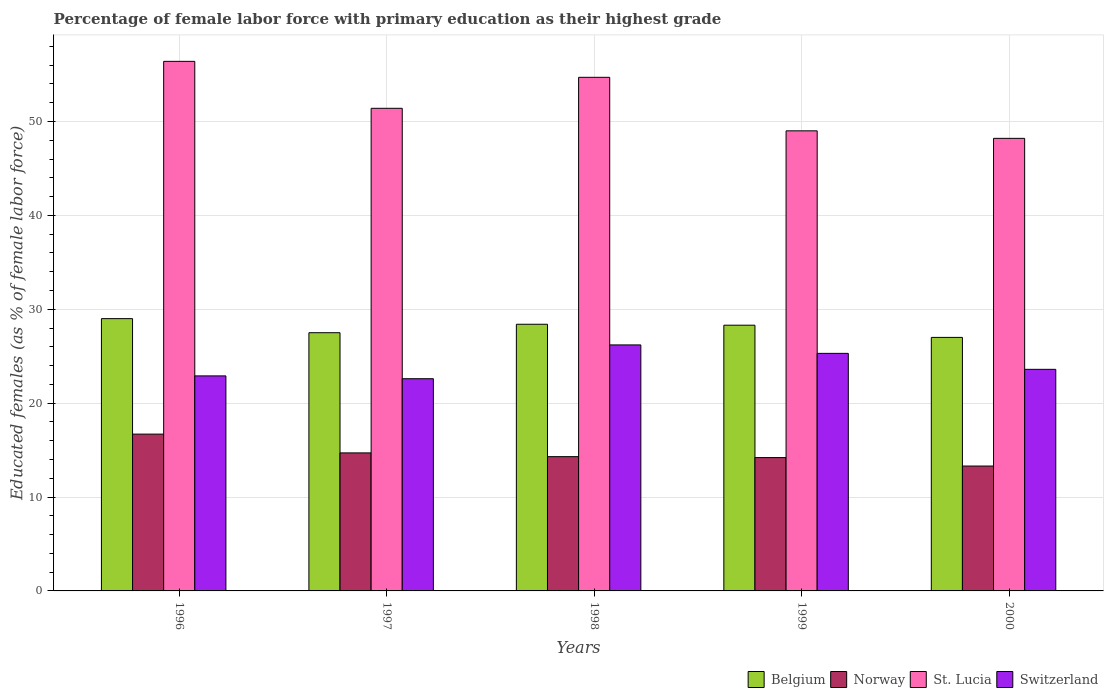How many groups of bars are there?
Offer a terse response. 5. Are the number of bars per tick equal to the number of legend labels?
Keep it short and to the point. Yes. How many bars are there on the 1st tick from the right?
Make the answer very short. 4. What is the label of the 3rd group of bars from the left?
Give a very brief answer. 1998. What is the percentage of female labor force with primary education in Switzerland in 1996?
Provide a succinct answer. 22.9. Across all years, what is the maximum percentage of female labor force with primary education in St. Lucia?
Provide a short and direct response. 56.4. Across all years, what is the minimum percentage of female labor force with primary education in Norway?
Make the answer very short. 13.3. In which year was the percentage of female labor force with primary education in Belgium maximum?
Keep it short and to the point. 1996. In which year was the percentage of female labor force with primary education in Belgium minimum?
Keep it short and to the point. 2000. What is the total percentage of female labor force with primary education in Norway in the graph?
Your answer should be compact. 73.2. What is the difference between the percentage of female labor force with primary education in Norway in 1997 and that in 1999?
Provide a succinct answer. 0.5. What is the difference between the percentage of female labor force with primary education in St. Lucia in 1997 and the percentage of female labor force with primary education in Norway in 1996?
Give a very brief answer. 34.7. What is the average percentage of female labor force with primary education in St. Lucia per year?
Your answer should be very brief. 51.94. In the year 1996, what is the difference between the percentage of female labor force with primary education in Belgium and percentage of female labor force with primary education in Norway?
Provide a short and direct response. 12.3. What is the ratio of the percentage of female labor force with primary education in St. Lucia in 1997 to that in 1999?
Offer a very short reply. 1.05. Is the percentage of female labor force with primary education in St. Lucia in 1996 less than that in 2000?
Provide a succinct answer. No. What is the difference between the highest and the second highest percentage of female labor force with primary education in Switzerland?
Your answer should be compact. 0.9. What is the difference between the highest and the lowest percentage of female labor force with primary education in Switzerland?
Offer a terse response. 3.6. Is the sum of the percentage of female labor force with primary education in Norway in 1999 and 2000 greater than the maximum percentage of female labor force with primary education in Switzerland across all years?
Give a very brief answer. Yes. What does the 3rd bar from the left in 1997 represents?
Offer a very short reply. St. Lucia. What does the 2nd bar from the right in 1996 represents?
Provide a succinct answer. St. Lucia. Is it the case that in every year, the sum of the percentage of female labor force with primary education in Norway and percentage of female labor force with primary education in St. Lucia is greater than the percentage of female labor force with primary education in Belgium?
Your answer should be very brief. Yes. What is the difference between two consecutive major ticks on the Y-axis?
Keep it short and to the point. 10. Are the values on the major ticks of Y-axis written in scientific E-notation?
Ensure brevity in your answer.  No. Does the graph contain any zero values?
Provide a short and direct response. No. Where does the legend appear in the graph?
Offer a very short reply. Bottom right. How many legend labels are there?
Make the answer very short. 4. What is the title of the graph?
Provide a short and direct response. Percentage of female labor force with primary education as their highest grade. Does "Ukraine" appear as one of the legend labels in the graph?
Give a very brief answer. No. What is the label or title of the X-axis?
Ensure brevity in your answer.  Years. What is the label or title of the Y-axis?
Give a very brief answer. Educated females (as % of female labor force). What is the Educated females (as % of female labor force) in Norway in 1996?
Make the answer very short. 16.7. What is the Educated females (as % of female labor force) in St. Lucia in 1996?
Provide a succinct answer. 56.4. What is the Educated females (as % of female labor force) in Switzerland in 1996?
Provide a short and direct response. 22.9. What is the Educated females (as % of female labor force) of Belgium in 1997?
Ensure brevity in your answer.  27.5. What is the Educated females (as % of female labor force) in Norway in 1997?
Provide a short and direct response. 14.7. What is the Educated females (as % of female labor force) of St. Lucia in 1997?
Make the answer very short. 51.4. What is the Educated females (as % of female labor force) in Switzerland in 1997?
Make the answer very short. 22.6. What is the Educated females (as % of female labor force) in Belgium in 1998?
Ensure brevity in your answer.  28.4. What is the Educated females (as % of female labor force) of Norway in 1998?
Offer a very short reply. 14.3. What is the Educated females (as % of female labor force) of St. Lucia in 1998?
Offer a very short reply. 54.7. What is the Educated females (as % of female labor force) in Switzerland in 1998?
Give a very brief answer. 26.2. What is the Educated females (as % of female labor force) in Belgium in 1999?
Keep it short and to the point. 28.3. What is the Educated females (as % of female labor force) of Norway in 1999?
Offer a terse response. 14.2. What is the Educated females (as % of female labor force) of St. Lucia in 1999?
Give a very brief answer. 49. What is the Educated females (as % of female labor force) in Switzerland in 1999?
Your answer should be compact. 25.3. What is the Educated females (as % of female labor force) in Norway in 2000?
Provide a succinct answer. 13.3. What is the Educated females (as % of female labor force) of St. Lucia in 2000?
Provide a succinct answer. 48.2. What is the Educated females (as % of female labor force) in Switzerland in 2000?
Keep it short and to the point. 23.6. Across all years, what is the maximum Educated females (as % of female labor force) in Norway?
Make the answer very short. 16.7. Across all years, what is the maximum Educated females (as % of female labor force) in St. Lucia?
Make the answer very short. 56.4. Across all years, what is the maximum Educated females (as % of female labor force) of Switzerland?
Make the answer very short. 26.2. Across all years, what is the minimum Educated females (as % of female labor force) in Norway?
Your answer should be compact. 13.3. Across all years, what is the minimum Educated females (as % of female labor force) in St. Lucia?
Offer a very short reply. 48.2. Across all years, what is the minimum Educated females (as % of female labor force) in Switzerland?
Your response must be concise. 22.6. What is the total Educated females (as % of female labor force) of Belgium in the graph?
Keep it short and to the point. 140.2. What is the total Educated females (as % of female labor force) in Norway in the graph?
Your answer should be very brief. 73.2. What is the total Educated females (as % of female labor force) of St. Lucia in the graph?
Give a very brief answer. 259.7. What is the total Educated females (as % of female labor force) in Switzerland in the graph?
Keep it short and to the point. 120.6. What is the difference between the Educated females (as % of female labor force) in Belgium in 1996 and that in 1997?
Provide a short and direct response. 1.5. What is the difference between the Educated females (as % of female labor force) of Norway in 1996 and that in 1997?
Keep it short and to the point. 2. What is the difference between the Educated females (as % of female labor force) in Switzerland in 1996 and that in 1997?
Make the answer very short. 0.3. What is the difference between the Educated females (as % of female labor force) in Belgium in 1996 and that in 1998?
Your response must be concise. 0.6. What is the difference between the Educated females (as % of female labor force) in St. Lucia in 1996 and that in 1998?
Make the answer very short. 1.7. What is the difference between the Educated females (as % of female labor force) in Norway in 1996 and that in 1999?
Give a very brief answer. 2.5. What is the difference between the Educated females (as % of female labor force) in St. Lucia in 1996 and that in 1999?
Provide a short and direct response. 7.4. What is the difference between the Educated females (as % of female labor force) of Switzerland in 1996 and that in 2000?
Make the answer very short. -0.7. What is the difference between the Educated females (as % of female labor force) of St. Lucia in 1997 and that in 1998?
Keep it short and to the point. -3.3. What is the difference between the Educated females (as % of female labor force) of Switzerland in 1997 and that in 1998?
Provide a succinct answer. -3.6. What is the difference between the Educated females (as % of female labor force) in Belgium in 1997 and that in 1999?
Your answer should be very brief. -0.8. What is the difference between the Educated females (as % of female labor force) in Norway in 1997 and that in 1999?
Your answer should be very brief. 0.5. What is the difference between the Educated females (as % of female labor force) of Switzerland in 1997 and that in 1999?
Ensure brevity in your answer.  -2.7. What is the difference between the Educated females (as % of female labor force) of Belgium in 1997 and that in 2000?
Your answer should be compact. 0.5. What is the difference between the Educated females (as % of female labor force) of Switzerland in 1997 and that in 2000?
Make the answer very short. -1. What is the difference between the Educated females (as % of female labor force) in Belgium in 1998 and that in 1999?
Provide a succinct answer. 0.1. What is the difference between the Educated females (as % of female labor force) of Norway in 1998 and that in 1999?
Ensure brevity in your answer.  0.1. What is the difference between the Educated females (as % of female labor force) in St. Lucia in 1998 and that in 1999?
Provide a succinct answer. 5.7. What is the difference between the Educated females (as % of female labor force) of Switzerland in 1998 and that in 1999?
Ensure brevity in your answer.  0.9. What is the difference between the Educated females (as % of female labor force) in Belgium in 1998 and that in 2000?
Keep it short and to the point. 1.4. What is the difference between the Educated females (as % of female labor force) of St. Lucia in 1998 and that in 2000?
Offer a terse response. 6.5. What is the difference between the Educated females (as % of female labor force) of Belgium in 1999 and that in 2000?
Offer a very short reply. 1.3. What is the difference between the Educated females (as % of female labor force) of St. Lucia in 1999 and that in 2000?
Offer a very short reply. 0.8. What is the difference between the Educated females (as % of female labor force) in Belgium in 1996 and the Educated females (as % of female labor force) in St. Lucia in 1997?
Keep it short and to the point. -22.4. What is the difference between the Educated females (as % of female labor force) in Belgium in 1996 and the Educated females (as % of female labor force) in Switzerland in 1997?
Give a very brief answer. 6.4. What is the difference between the Educated females (as % of female labor force) of Norway in 1996 and the Educated females (as % of female labor force) of St. Lucia in 1997?
Provide a short and direct response. -34.7. What is the difference between the Educated females (as % of female labor force) of Norway in 1996 and the Educated females (as % of female labor force) of Switzerland in 1997?
Your response must be concise. -5.9. What is the difference between the Educated females (as % of female labor force) of St. Lucia in 1996 and the Educated females (as % of female labor force) of Switzerland in 1997?
Give a very brief answer. 33.8. What is the difference between the Educated females (as % of female labor force) of Belgium in 1996 and the Educated females (as % of female labor force) of Norway in 1998?
Your response must be concise. 14.7. What is the difference between the Educated females (as % of female labor force) in Belgium in 1996 and the Educated females (as % of female labor force) in St. Lucia in 1998?
Give a very brief answer. -25.7. What is the difference between the Educated females (as % of female labor force) of Belgium in 1996 and the Educated females (as % of female labor force) of Switzerland in 1998?
Your answer should be compact. 2.8. What is the difference between the Educated females (as % of female labor force) of Norway in 1996 and the Educated females (as % of female labor force) of St. Lucia in 1998?
Give a very brief answer. -38. What is the difference between the Educated females (as % of female labor force) in St. Lucia in 1996 and the Educated females (as % of female labor force) in Switzerland in 1998?
Provide a succinct answer. 30.2. What is the difference between the Educated females (as % of female labor force) in Belgium in 1996 and the Educated females (as % of female labor force) in St. Lucia in 1999?
Keep it short and to the point. -20. What is the difference between the Educated females (as % of female labor force) in Norway in 1996 and the Educated females (as % of female labor force) in St. Lucia in 1999?
Offer a terse response. -32.3. What is the difference between the Educated females (as % of female labor force) of Norway in 1996 and the Educated females (as % of female labor force) of Switzerland in 1999?
Give a very brief answer. -8.6. What is the difference between the Educated females (as % of female labor force) in St. Lucia in 1996 and the Educated females (as % of female labor force) in Switzerland in 1999?
Keep it short and to the point. 31.1. What is the difference between the Educated females (as % of female labor force) in Belgium in 1996 and the Educated females (as % of female labor force) in St. Lucia in 2000?
Give a very brief answer. -19.2. What is the difference between the Educated females (as % of female labor force) of Belgium in 1996 and the Educated females (as % of female labor force) of Switzerland in 2000?
Keep it short and to the point. 5.4. What is the difference between the Educated females (as % of female labor force) in Norway in 1996 and the Educated females (as % of female labor force) in St. Lucia in 2000?
Offer a very short reply. -31.5. What is the difference between the Educated females (as % of female labor force) in St. Lucia in 1996 and the Educated females (as % of female labor force) in Switzerland in 2000?
Give a very brief answer. 32.8. What is the difference between the Educated females (as % of female labor force) in Belgium in 1997 and the Educated females (as % of female labor force) in St. Lucia in 1998?
Offer a terse response. -27.2. What is the difference between the Educated females (as % of female labor force) in Belgium in 1997 and the Educated females (as % of female labor force) in Switzerland in 1998?
Offer a terse response. 1.3. What is the difference between the Educated females (as % of female labor force) of Norway in 1997 and the Educated females (as % of female labor force) of St. Lucia in 1998?
Provide a succinct answer. -40. What is the difference between the Educated females (as % of female labor force) of St. Lucia in 1997 and the Educated females (as % of female labor force) of Switzerland in 1998?
Make the answer very short. 25.2. What is the difference between the Educated females (as % of female labor force) in Belgium in 1997 and the Educated females (as % of female labor force) in St. Lucia in 1999?
Provide a succinct answer. -21.5. What is the difference between the Educated females (as % of female labor force) of Belgium in 1997 and the Educated females (as % of female labor force) of Switzerland in 1999?
Provide a succinct answer. 2.2. What is the difference between the Educated females (as % of female labor force) in Norway in 1997 and the Educated females (as % of female labor force) in St. Lucia in 1999?
Offer a very short reply. -34.3. What is the difference between the Educated females (as % of female labor force) of St. Lucia in 1997 and the Educated females (as % of female labor force) of Switzerland in 1999?
Give a very brief answer. 26.1. What is the difference between the Educated females (as % of female labor force) of Belgium in 1997 and the Educated females (as % of female labor force) of Norway in 2000?
Ensure brevity in your answer.  14.2. What is the difference between the Educated females (as % of female labor force) of Belgium in 1997 and the Educated females (as % of female labor force) of St. Lucia in 2000?
Make the answer very short. -20.7. What is the difference between the Educated females (as % of female labor force) in Norway in 1997 and the Educated females (as % of female labor force) in St. Lucia in 2000?
Provide a short and direct response. -33.5. What is the difference between the Educated females (as % of female labor force) of St. Lucia in 1997 and the Educated females (as % of female labor force) of Switzerland in 2000?
Provide a short and direct response. 27.8. What is the difference between the Educated females (as % of female labor force) of Belgium in 1998 and the Educated females (as % of female labor force) of St. Lucia in 1999?
Give a very brief answer. -20.6. What is the difference between the Educated females (as % of female labor force) in Norway in 1998 and the Educated females (as % of female labor force) in St. Lucia in 1999?
Ensure brevity in your answer.  -34.7. What is the difference between the Educated females (as % of female labor force) in Norway in 1998 and the Educated females (as % of female labor force) in Switzerland in 1999?
Your answer should be compact. -11. What is the difference between the Educated females (as % of female labor force) of St. Lucia in 1998 and the Educated females (as % of female labor force) of Switzerland in 1999?
Provide a succinct answer. 29.4. What is the difference between the Educated females (as % of female labor force) of Belgium in 1998 and the Educated females (as % of female labor force) of St. Lucia in 2000?
Give a very brief answer. -19.8. What is the difference between the Educated females (as % of female labor force) of Belgium in 1998 and the Educated females (as % of female labor force) of Switzerland in 2000?
Provide a succinct answer. 4.8. What is the difference between the Educated females (as % of female labor force) of Norway in 1998 and the Educated females (as % of female labor force) of St. Lucia in 2000?
Offer a terse response. -33.9. What is the difference between the Educated females (as % of female labor force) in Norway in 1998 and the Educated females (as % of female labor force) in Switzerland in 2000?
Your response must be concise. -9.3. What is the difference between the Educated females (as % of female labor force) of St. Lucia in 1998 and the Educated females (as % of female labor force) of Switzerland in 2000?
Make the answer very short. 31.1. What is the difference between the Educated females (as % of female labor force) in Belgium in 1999 and the Educated females (as % of female labor force) in Norway in 2000?
Ensure brevity in your answer.  15. What is the difference between the Educated females (as % of female labor force) in Belgium in 1999 and the Educated females (as % of female labor force) in St. Lucia in 2000?
Provide a short and direct response. -19.9. What is the difference between the Educated females (as % of female labor force) in Norway in 1999 and the Educated females (as % of female labor force) in St. Lucia in 2000?
Your answer should be very brief. -34. What is the difference between the Educated females (as % of female labor force) in Norway in 1999 and the Educated females (as % of female labor force) in Switzerland in 2000?
Make the answer very short. -9.4. What is the difference between the Educated females (as % of female labor force) in St. Lucia in 1999 and the Educated females (as % of female labor force) in Switzerland in 2000?
Provide a short and direct response. 25.4. What is the average Educated females (as % of female labor force) of Belgium per year?
Offer a very short reply. 28.04. What is the average Educated females (as % of female labor force) of Norway per year?
Offer a very short reply. 14.64. What is the average Educated females (as % of female labor force) in St. Lucia per year?
Ensure brevity in your answer.  51.94. What is the average Educated females (as % of female labor force) of Switzerland per year?
Give a very brief answer. 24.12. In the year 1996, what is the difference between the Educated females (as % of female labor force) of Belgium and Educated females (as % of female labor force) of St. Lucia?
Your answer should be compact. -27.4. In the year 1996, what is the difference between the Educated females (as % of female labor force) of Belgium and Educated females (as % of female labor force) of Switzerland?
Offer a very short reply. 6.1. In the year 1996, what is the difference between the Educated females (as % of female labor force) of Norway and Educated females (as % of female labor force) of St. Lucia?
Provide a succinct answer. -39.7. In the year 1996, what is the difference between the Educated females (as % of female labor force) of Norway and Educated females (as % of female labor force) of Switzerland?
Give a very brief answer. -6.2. In the year 1996, what is the difference between the Educated females (as % of female labor force) of St. Lucia and Educated females (as % of female labor force) of Switzerland?
Make the answer very short. 33.5. In the year 1997, what is the difference between the Educated females (as % of female labor force) in Belgium and Educated females (as % of female labor force) in Norway?
Offer a terse response. 12.8. In the year 1997, what is the difference between the Educated females (as % of female labor force) of Belgium and Educated females (as % of female labor force) of St. Lucia?
Provide a short and direct response. -23.9. In the year 1997, what is the difference between the Educated females (as % of female labor force) in Belgium and Educated females (as % of female labor force) in Switzerland?
Ensure brevity in your answer.  4.9. In the year 1997, what is the difference between the Educated females (as % of female labor force) of Norway and Educated females (as % of female labor force) of St. Lucia?
Offer a terse response. -36.7. In the year 1997, what is the difference between the Educated females (as % of female labor force) in Norway and Educated females (as % of female labor force) in Switzerland?
Ensure brevity in your answer.  -7.9. In the year 1997, what is the difference between the Educated females (as % of female labor force) of St. Lucia and Educated females (as % of female labor force) of Switzerland?
Make the answer very short. 28.8. In the year 1998, what is the difference between the Educated females (as % of female labor force) in Belgium and Educated females (as % of female labor force) in St. Lucia?
Ensure brevity in your answer.  -26.3. In the year 1998, what is the difference between the Educated females (as % of female labor force) of Belgium and Educated females (as % of female labor force) of Switzerland?
Your answer should be very brief. 2.2. In the year 1998, what is the difference between the Educated females (as % of female labor force) in Norway and Educated females (as % of female labor force) in St. Lucia?
Give a very brief answer. -40.4. In the year 1998, what is the difference between the Educated females (as % of female labor force) of St. Lucia and Educated females (as % of female labor force) of Switzerland?
Your answer should be compact. 28.5. In the year 1999, what is the difference between the Educated females (as % of female labor force) of Belgium and Educated females (as % of female labor force) of St. Lucia?
Your answer should be very brief. -20.7. In the year 1999, what is the difference between the Educated females (as % of female labor force) of Norway and Educated females (as % of female labor force) of St. Lucia?
Keep it short and to the point. -34.8. In the year 1999, what is the difference between the Educated females (as % of female labor force) of Norway and Educated females (as % of female labor force) of Switzerland?
Make the answer very short. -11.1. In the year 1999, what is the difference between the Educated females (as % of female labor force) in St. Lucia and Educated females (as % of female labor force) in Switzerland?
Your response must be concise. 23.7. In the year 2000, what is the difference between the Educated females (as % of female labor force) in Belgium and Educated females (as % of female labor force) in Norway?
Offer a terse response. 13.7. In the year 2000, what is the difference between the Educated females (as % of female labor force) in Belgium and Educated females (as % of female labor force) in St. Lucia?
Your answer should be very brief. -21.2. In the year 2000, what is the difference between the Educated females (as % of female labor force) in Belgium and Educated females (as % of female labor force) in Switzerland?
Your answer should be very brief. 3.4. In the year 2000, what is the difference between the Educated females (as % of female labor force) in Norway and Educated females (as % of female labor force) in St. Lucia?
Offer a terse response. -34.9. In the year 2000, what is the difference between the Educated females (as % of female labor force) of Norway and Educated females (as % of female labor force) of Switzerland?
Your answer should be compact. -10.3. In the year 2000, what is the difference between the Educated females (as % of female labor force) in St. Lucia and Educated females (as % of female labor force) in Switzerland?
Make the answer very short. 24.6. What is the ratio of the Educated females (as % of female labor force) in Belgium in 1996 to that in 1997?
Give a very brief answer. 1.05. What is the ratio of the Educated females (as % of female labor force) of Norway in 1996 to that in 1997?
Ensure brevity in your answer.  1.14. What is the ratio of the Educated females (as % of female labor force) in St. Lucia in 1996 to that in 1997?
Provide a succinct answer. 1.1. What is the ratio of the Educated females (as % of female labor force) in Switzerland in 1996 to that in 1997?
Your response must be concise. 1.01. What is the ratio of the Educated females (as % of female labor force) in Belgium in 1996 to that in 1998?
Your response must be concise. 1.02. What is the ratio of the Educated females (as % of female labor force) in Norway in 1996 to that in 1998?
Provide a succinct answer. 1.17. What is the ratio of the Educated females (as % of female labor force) in St. Lucia in 1996 to that in 1998?
Provide a succinct answer. 1.03. What is the ratio of the Educated females (as % of female labor force) of Switzerland in 1996 to that in 1998?
Your answer should be very brief. 0.87. What is the ratio of the Educated females (as % of female labor force) in Belgium in 1996 to that in 1999?
Offer a terse response. 1.02. What is the ratio of the Educated females (as % of female labor force) of Norway in 1996 to that in 1999?
Offer a very short reply. 1.18. What is the ratio of the Educated females (as % of female labor force) in St. Lucia in 1996 to that in 1999?
Ensure brevity in your answer.  1.15. What is the ratio of the Educated females (as % of female labor force) of Switzerland in 1996 to that in 1999?
Keep it short and to the point. 0.91. What is the ratio of the Educated females (as % of female labor force) of Belgium in 1996 to that in 2000?
Provide a short and direct response. 1.07. What is the ratio of the Educated females (as % of female labor force) in Norway in 1996 to that in 2000?
Offer a very short reply. 1.26. What is the ratio of the Educated females (as % of female labor force) of St. Lucia in 1996 to that in 2000?
Provide a succinct answer. 1.17. What is the ratio of the Educated females (as % of female labor force) in Switzerland in 1996 to that in 2000?
Offer a terse response. 0.97. What is the ratio of the Educated females (as % of female labor force) in Belgium in 1997 to that in 1998?
Ensure brevity in your answer.  0.97. What is the ratio of the Educated females (as % of female labor force) of Norway in 1997 to that in 1998?
Ensure brevity in your answer.  1.03. What is the ratio of the Educated females (as % of female labor force) of St. Lucia in 1997 to that in 1998?
Your answer should be very brief. 0.94. What is the ratio of the Educated females (as % of female labor force) in Switzerland in 1997 to that in 1998?
Your answer should be very brief. 0.86. What is the ratio of the Educated females (as % of female labor force) of Belgium in 1997 to that in 1999?
Offer a very short reply. 0.97. What is the ratio of the Educated females (as % of female labor force) in Norway in 1997 to that in 1999?
Provide a short and direct response. 1.04. What is the ratio of the Educated females (as % of female labor force) of St. Lucia in 1997 to that in 1999?
Provide a short and direct response. 1.05. What is the ratio of the Educated females (as % of female labor force) of Switzerland in 1997 to that in 1999?
Provide a succinct answer. 0.89. What is the ratio of the Educated females (as % of female labor force) in Belgium in 1997 to that in 2000?
Your answer should be compact. 1.02. What is the ratio of the Educated females (as % of female labor force) of Norway in 1997 to that in 2000?
Make the answer very short. 1.11. What is the ratio of the Educated females (as % of female labor force) in St. Lucia in 1997 to that in 2000?
Provide a succinct answer. 1.07. What is the ratio of the Educated females (as % of female labor force) in Switzerland in 1997 to that in 2000?
Provide a succinct answer. 0.96. What is the ratio of the Educated females (as % of female labor force) in Norway in 1998 to that in 1999?
Offer a very short reply. 1.01. What is the ratio of the Educated females (as % of female labor force) in St. Lucia in 1998 to that in 1999?
Your answer should be compact. 1.12. What is the ratio of the Educated females (as % of female labor force) in Switzerland in 1998 to that in 1999?
Your answer should be compact. 1.04. What is the ratio of the Educated females (as % of female labor force) of Belgium in 1998 to that in 2000?
Your response must be concise. 1.05. What is the ratio of the Educated females (as % of female labor force) in Norway in 1998 to that in 2000?
Provide a succinct answer. 1.08. What is the ratio of the Educated females (as % of female labor force) of St. Lucia in 1998 to that in 2000?
Make the answer very short. 1.13. What is the ratio of the Educated females (as % of female labor force) in Switzerland in 1998 to that in 2000?
Keep it short and to the point. 1.11. What is the ratio of the Educated females (as % of female labor force) of Belgium in 1999 to that in 2000?
Provide a short and direct response. 1.05. What is the ratio of the Educated females (as % of female labor force) of Norway in 1999 to that in 2000?
Offer a very short reply. 1.07. What is the ratio of the Educated females (as % of female labor force) in St. Lucia in 1999 to that in 2000?
Provide a short and direct response. 1.02. What is the ratio of the Educated females (as % of female labor force) in Switzerland in 1999 to that in 2000?
Your response must be concise. 1.07. What is the difference between the highest and the second highest Educated females (as % of female labor force) in Switzerland?
Keep it short and to the point. 0.9. What is the difference between the highest and the lowest Educated females (as % of female labor force) of Belgium?
Offer a terse response. 2. What is the difference between the highest and the lowest Educated females (as % of female labor force) of Norway?
Provide a short and direct response. 3.4. What is the difference between the highest and the lowest Educated females (as % of female labor force) of St. Lucia?
Make the answer very short. 8.2. 